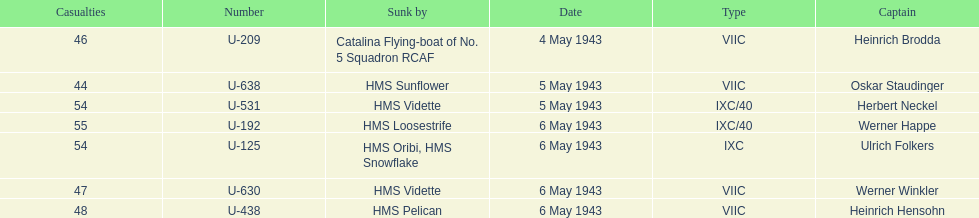Which ship sunk the most u-boats HMS Vidette. 